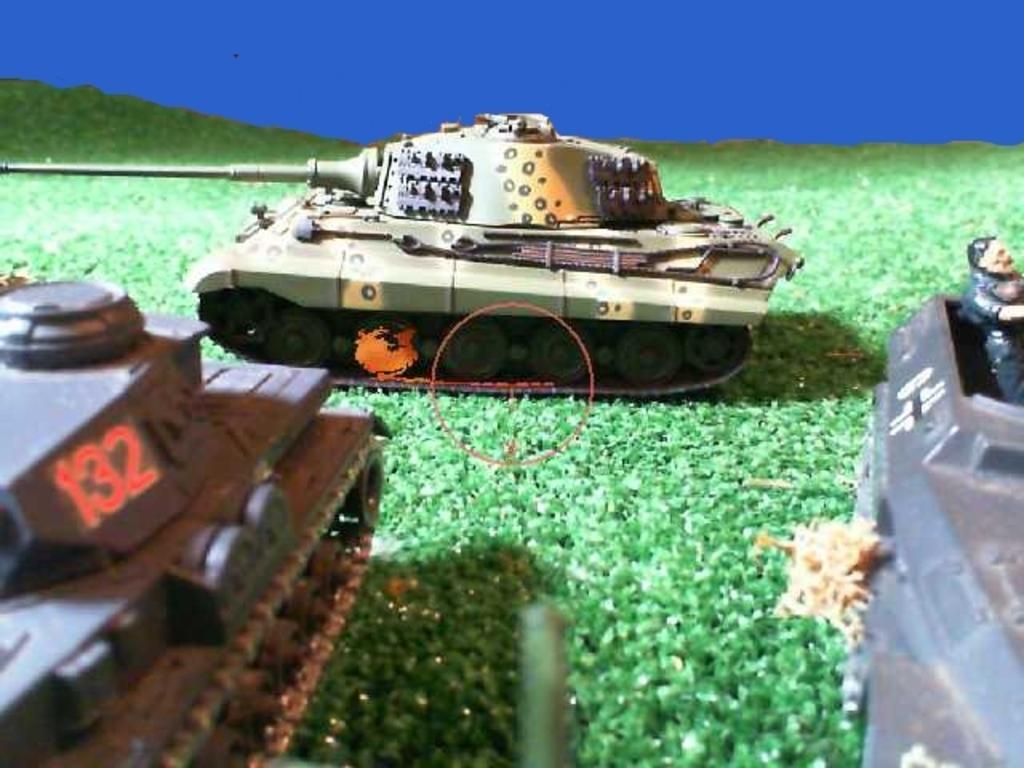Describe this image in one or two sentences. In this picture I can see some toy vehicles are placed on the artificial grass. 